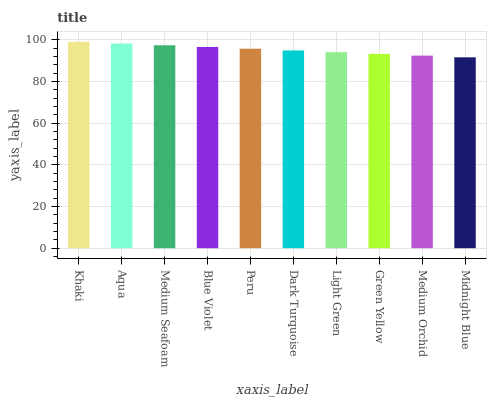Is Aqua the minimum?
Answer yes or no. No. Is Aqua the maximum?
Answer yes or no. No. Is Khaki greater than Aqua?
Answer yes or no. Yes. Is Aqua less than Khaki?
Answer yes or no. Yes. Is Aqua greater than Khaki?
Answer yes or no. No. Is Khaki less than Aqua?
Answer yes or no. No. Is Peru the high median?
Answer yes or no. Yes. Is Dark Turquoise the low median?
Answer yes or no. Yes. Is Blue Violet the high median?
Answer yes or no. No. Is Khaki the low median?
Answer yes or no. No. 